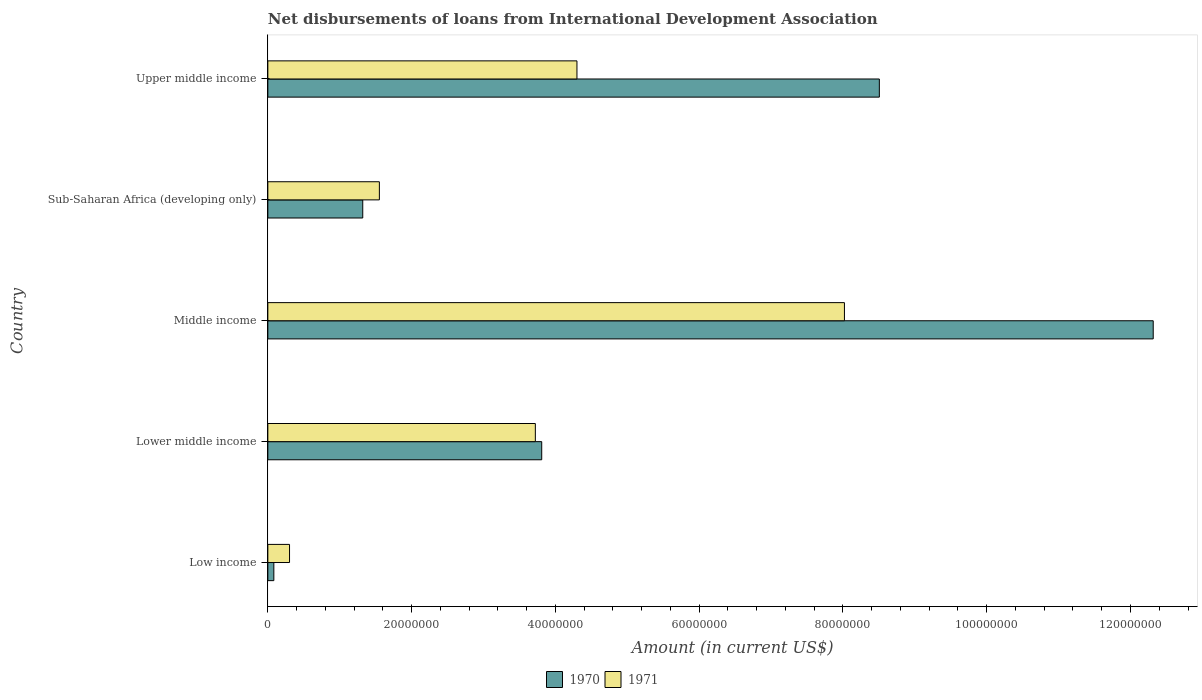How many different coloured bars are there?
Your response must be concise. 2. Are the number of bars per tick equal to the number of legend labels?
Your response must be concise. Yes. Are the number of bars on each tick of the Y-axis equal?
Offer a terse response. Yes. How many bars are there on the 5th tick from the top?
Provide a succinct answer. 2. What is the label of the 1st group of bars from the top?
Offer a very short reply. Upper middle income. What is the amount of loans disbursed in 1971 in Middle income?
Make the answer very short. 8.02e+07. Across all countries, what is the maximum amount of loans disbursed in 1970?
Your answer should be very brief. 1.23e+08. Across all countries, what is the minimum amount of loans disbursed in 1971?
Offer a very short reply. 3.02e+06. In which country was the amount of loans disbursed in 1971 maximum?
Provide a short and direct response. Middle income. What is the total amount of loans disbursed in 1971 in the graph?
Your response must be concise. 1.79e+08. What is the difference between the amount of loans disbursed in 1970 in Lower middle income and that in Sub-Saharan Africa (developing only)?
Offer a very short reply. 2.49e+07. What is the difference between the amount of loans disbursed in 1971 in Upper middle income and the amount of loans disbursed in 1970 in Sub-Saharan Africa (developing only)?
Make the answer very short. 2.98e+07. What is the average amount of loans disbursed in 1971 per country?
Your response must be concise. 3.58e+07. What is the difference between the amount of loans disbursed in 1970 and amount of loans disbursed in 1971 in Upper middle income?
Provide a succinct answer. 4.21e+07. In how many countries, is the amount of loans disbursed in 1970 greater than 108000000 US$?
Provide a short and direct response. 1. What is the ratio of the amount of loans disbursed in 1971 in Low income to that in Middle income?
Give a very brief answer. 0.04. Is the difference between the amount of loans disbursed in 1970 in Lower middle income and Upper middle income greater than the difference between the amount of loans disbursed in 1971 in Lower middle income and Upper middle income?
Offer a very short reply. No. What is the difference between the highest and the second highest amount of loans disbursed in 1971?
Give a very brief answer. 3.72e+07. What is the difference between the highest and the lowest amount of loans disbursed in 1970?
Your answer should be very brief. 1.22e+08. In how many countries, is the amount of loans disbursed in 1971 greater than the average amount of loans disbursed in 1971 taken over all countries?
Your answer should be compact. 3. Is the sum of the amount of loans disbursed in 1970 in Low income and Upper middle income greater than the maximum amount of loans disbursed in 1971 across all countries?
Keep it short and to the point. Yes. What does the 2nd bar from the top in Upper middle income represents?
Your response must be concise. 1970. How many bars are there?
Offer a very short reply. 10. Are all the bars in the graph horizontal?
Your answer should be very brief. Yes. How many countries are there in the graph?
Offer a very short reply. 5. Does the graph contain any zero values?
Your answer should be compact. No. What is the title of the graph?
Offer a terse response. Net disbursements of loans from International Development Association. What is the label or title of the Y-axis?
Ensure brevity in your answer.  Country. What is the Amount (in current US$) of 1970 in Low income?
Offer a very short reply. 8.35e+05. What is the Amount (in current US$) of 1971 in Low income?
Offer a very short reply. 3.02e+06. What is the Amount (in current US$) of 1970 in Lower middle income?
Offer a very short reply. 3.81e+07. What is the Amount (in current US$) of 1971 in Lower middle income?
Your response must be concise. 3.72e+07. What is the Amount (in current US$) of 1970 in Middle income?
Offer a very short reply. 1.23e+08. What is the Amount (in current US$) of 1971 in Middle income?
Provide a short and direct response. 8.02e+07. What is the Amount (in current US$) of 1970 in Sub-Saharan Africa (developing only)?
Your answer should be compact. 1.32e+07. What is the Amount (in current US$) in 1971 in Sub-Saharan Africa (developing only)?
Your answer should be compact. 1.55e+07. What is the Amount (in current US$) in 1970 in Upper middle income?
Provide a short and direct response. 8.51e+07. What is the Amount (in current US$) of 1971 in Upper middle income?
Make the answer very short. 4.30e+07. Across all countries, what is the maximum Amount (in current US$) in 1970?
Your answer should be compact. 1.23e+08. Across all countries, what is the maximum Amount (in current US$) in 1971?
Keep it short and to the point. 8.02e+07. Across all countries, what is the minimum Amount (in current US$) of 1970?
Your answer should be compact. 8.35e+05. Across all countries, what is the minimum Amount (in current US$) of 1971?
Offer a terse response. 3.02e+06. What is the total Amount (in current US$) of 1970 in the graph?
Provide a short and direct response. 2.60e+08. What is the total Amount (in current US$) of 1971 in the graph?
Provide a short and direct response. 1.79e+08. What is the difference between the Amount (in current US$) of 1970 in Low income and that in Lower middle income?
Give a very brief answer. -3.73e+07. What is the difference between the Amount (in current US$) in 1971 in Low income and that in Lower middle income?
Your answer should be very brief. -3.42e+07. What is the difference between the Amount (in current US$) in 1970 in Low income and that in Middle income?
Keep it short and to the point. -1.22e+08. What is the difference between the Amount (in current US$) in 1971 in Low income and that in Middle income?
Your answer should be very brief. -7.72e+07. What is the difference between the Amount (in current US$) of 1970 in Low income and that in Sub-Saharan Africa (developing only)?
Ensure brevity in your answer.  -1.24e+07. What is the difference between the Amount (in current US$) in 1971 in Low income and that in Sub-Saharan Africa (developing only)?
Your response must be concise. -1.25e+07. What is the difference between the Amount (in current US$) in 1970 in Low income and that in Upper middle income?
Ensure brevity in your answer.  -8.42e+07. What is the difference between the Amount (in current US$) of 1971 in Low income and that in Upper middle income?
Your answer should be compact. -4.00e+07. What is the difference between the Amount (in current US$) in 1970 in Lower middle income and that in Middle income?
Your answer should be compact. -8.51e+07. What is the difference between the Amount (in current US$) in 1971 in Lower middle income and that in Middle income?
Ensure brevity in your answer.  -4.30e+07. What is the difference between the Amount (in current US$) in 1970 in Lower middle income and that in Sub-Saharan Africa (developing only)?
Your answer should be compact. 2.49e+07. What is the difference between the Amount (in current US$) in 1971 in Lower middle income and that in Sub-Saharan Africa (developing only)?
Ensure brevity in your answer.  2.17e+07. What is the difference between the Amount (in current US$) in 1970 in Lower middle income and that in Upper middle income?
Your answer should be compact. -4.70e+07. What is the difference between the Amount (in current US$) in 1971 in Lower middle income and that in Upper middle income?
Give a very brief answer. -5.79e+06. What is the difference between the Amount (in current US$) of 1970 in Middle income and that in Sub-Saharan Africa (developing only)?
Provide a succinct answer. 1.10e+08. What is the difference between the Amount (in current US$) of 1971 in Middle income and that in Sub-Saharan Africa (developing only)?
Your answer should be very brief. 6.47e+07. What is the difference between the Amount (in current US$) of 1970 in Middle income and that in Upper middle income?
Provide a succinct answer. 3.81e+07. What is the difference between the Amount (in current US$) of 1971 in Middle income and that in Upper middle income?
Your response must be concise. 3.72e+07. What is the difference between the Amount (in current US$) in 1970 in Sub-Saharan Africa (developing only) and that in Upper middle income?
Provide a succinct answer. -7.19e+07. What is the difference between the Amount (in current US$) of 1971 in Sub-Saharan Africa (developing only) and that in Upper middle income?
Your response must be concise. -2.75e+07. What is the difference between the Amount (in current US$) in 1970 in Low income and the Amount (in current US$) in 1971 in Lower middle income?
Your response must be concise. -3.64e+07. What is the difference between the Amount (in current US$) in 1970 in Low income and the Amount (in current US$) in 1971 in Middle income?
Offer a very short reply. -7.94e+07. What is the difference between the Amount (in current US$) of 1970 in Low income and the Amount (in current US$) of 1971 in Sub-Saharan Africa (developing only)?
Offer a terse response. -1.47e+07. What is the difference between the Amount (in current US$) in 1970 in Low income and the Amount (in current US$) in 1971 in Upper middle income?
Provide a short and direct response. -4.22e+07. What is the difference between the Amount (in current US$) in 1970 in Lower middle income and the Amount (in current US$) in 1971 in Middle income?
Give a very brief answer. -4.21e+07. What is the difference between the Amount (in current US$) in 1970 in Lower middle income and the Amount (in current US$) in 1971 in Sub-Saharan Africa (developing only)?
Provide a short and direct response. 2.26e+07. What is the difference between the Amount (in current US$) in 1970 in Lower middle income and the Amount (in current US$) in 1971 in Upper middle income?
Provide a succinct answer. -4.90e+06. What is the difference between the Amount (in current US$) of 1970 in Middle income and the Amount (in current US$) of 1971 in Sub-Saharan Africa (developing only)?
Offer a terse response. 1.08e+08. What is the difference between the Amount (in current US$) of 1970 in Middle income and the Amount (in current US$) of 1971 in Upper middle income?
Keep it short and to the point. 8.02e+07. What is the difference between the Amount (in current US$) of 1970 in Sub-Saharan Africa (developing only) and the Amount (in current US$) of 1971 in Upper middle income?
Your answer should be compact. -2.98e+07. What is the average Amount (in current US$) of 1970 per country?
Keep it short and to the point. 5.21e+07. What is the average Amount (in current US$) in 1971 per country?
Your response must be concise. 3.58e+07. What is the difference between the Amount (in current US$) of 1970 and Amount (in current US$) of 1971 in Low income?
Offer a terse response. -2.18e+06. What is the difference between the Amount (in current US$) of 1970 and Amount (in current US$) of 1971 in Lower middle income?
Your answer should be compact. 8.88e+05. What is the difference between the Amount (in current US$) of 1970 and Amount (in current US$) of 1971 in Middle income?
Give a very brief answer. 4.30e+07. What is the difference between the Amount (in current US$) in 1970 and Amount (in current US$) in 1971 in Sub-Saharan Africa (developing only)?
Your answer should be very brief. -2.31e+06. What is the difference between the Amount (in current US$) of 1970 and Amount (in current US$) of 1971 in Upper middle income?
Your answer should be compact. 4.21e+07. What is the ratio of the Amount (in current US$) in 1970 in Low income to that in Lower middle income?
Offer a very short reply. 0.02. What is the ratio of the Amount (in current US$) of 1971 in Low income to that in Lower middle income?
Your response must be concise. 0.08. What is the ratio of the Amount (in current US$) in 1970 in Low income to that in Middle income?
Give a very brief answer. 0.01. What is the ratio of the Amount (in current US$) in 1971 in Low income to that in Middle income?
Give a very brief answer. 0.04. What is the ratio of the Amount (in current US$) of 1970 in Low income to that in Sub-Saharan Africa (developing only)?
Your answer should be compact. 0.06. What is the ratio of the Amount (in current US$) of 1971 in Low income to that in Sub-Saharan Africa (developing only)?
Your response must be concise. 0.19. What is the ratio of the Amount (in current US$) of 1970 in Low income to that in Upper middle income?
Offer a terse response. 0.01. What is the ratio of the Amount (in current US$) of 1971 in Low income to that in Upper middle income?
Provide a short and direct response. 0.07. What is the ratio of the Amount (in current US$) of 1970 in Lower middle income to that in Middle income?
Provide a succinct answer. 0.31. What is the ratio of the Amount (in current US$) in 1971 in Lower middle income to that in Middle income?
Offer a terse response. 0.46. What is the ratio of the Amount (in current US$) of 1970 in Lower middle income to that in Sub-Saharan Africa (developing only)?
Offer a very short reply. 2.89. What is the ratio of the Amount (in current US$) in 1971 in Lower middle income to that in Sub-Saharan Africa (developing only)?
Your answer should be very brief. 2.4. What is the ratio of the Amount (in current US$) in 1970 in Lower middle income to that in Upper middle income?
Give a very brief answer. 0.45. What is the ratio of the Amount (in current US$) of 1971 in Lower middle income to that in Upper middle income?
Offer a very short reply. 0.87. What is the ratio of the Amount (in current US$) in 1970 in Middle income to that in Sub-Saharan Africa (developing only)?
Provide a short and direct response. 9.33. What is the ratio of the Amount (in current US$) of 1971 in Middle income to that in Sub-Saharan Africa (developing only)?
Ensure brevity in your answer.  5.17. What is the ratio of the Amount (in current US$) of 1970 in Middle income to that in Upper middle income?
Provide a short and direct response. 1.45. What is the ratio of the Amount (in current US$) in 1971 in Middle income to that in Upper middle income?
Your response must be concise. 1.87. What is the ratio of the Amount (in current US$) in 1970 in Sub-Saharan Africa (developing only) to that in Upper middle income?
Keep it short and to the point. 0.16. What is the ratio of the Amount (in current US$) of 1971 in Sub-Saharan Africa (developing only) to that in Upper middle income?
Your answer should be very brief. 0.36. What is the difference between the highest and the second highest Amount (in current US$) in 1970?
Give a very brief answer. 3.81e+07. What is the difference between the highest and the second highest Amount (in current US$) of 1971?
Ensure brevity in your answer.  3.72e+07. What is the difference between the highest and the lowest Amount (in current US$) in 1970?
Provide a succinct answer. 1.22e+08. What is the difference between the highest and the lowest Amount (in current US$) in 1971?
Keep it short and to the point. 7.72e+07. 